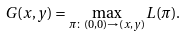<formula> <loc_0><loc_0><loc_500><loc_500>G ( x , y ) = \max _ { \pi \colon ( 0 , 0 ) \to ( x , y ) } L ( \pi ) .</formula> 